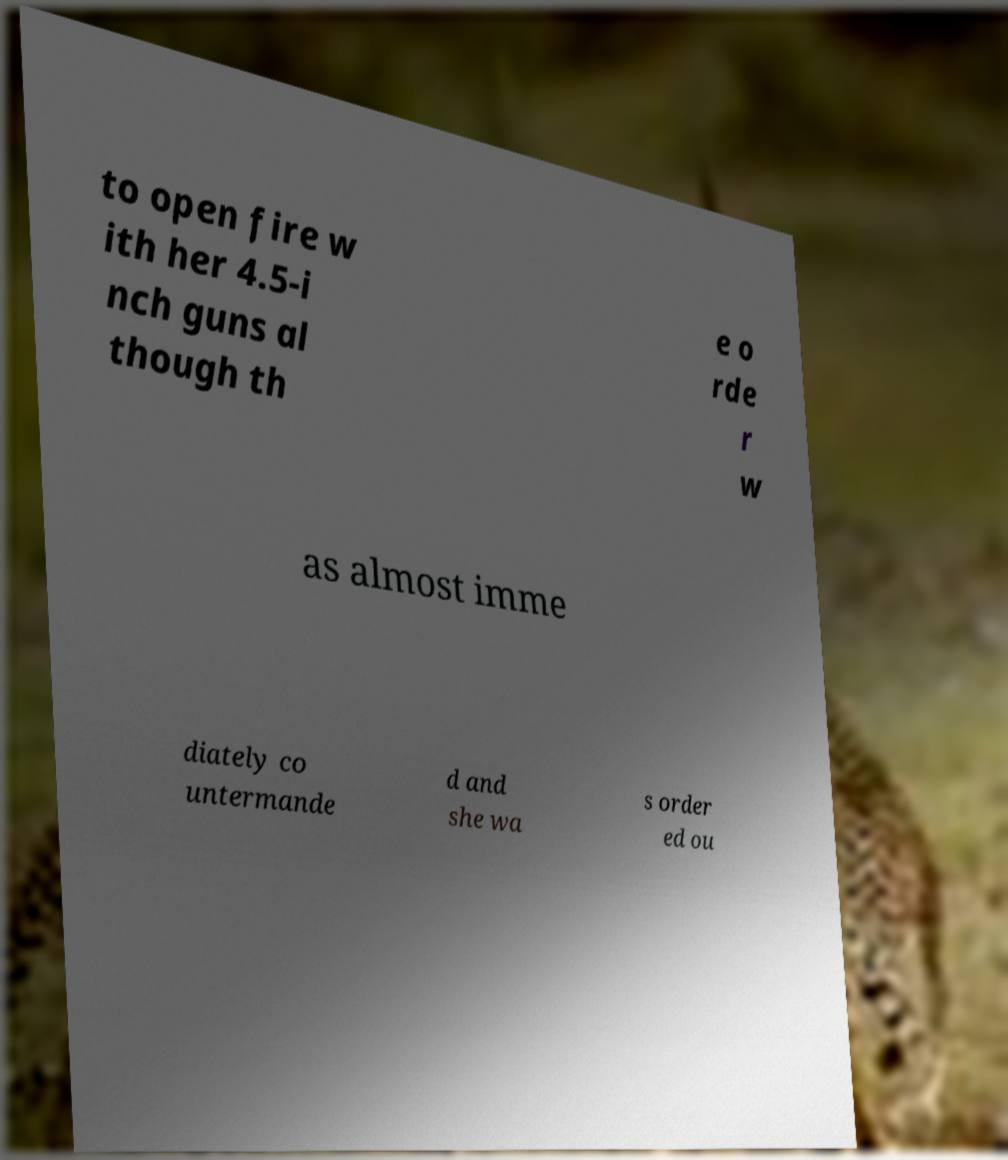There's text embedded in this image that I need extracted. Can you transcribe it verbatim? to open fire w ith her 4.5-i nch guns al though th e o rde r w as almost imme diately co untermande d and she wa s order ed ou 